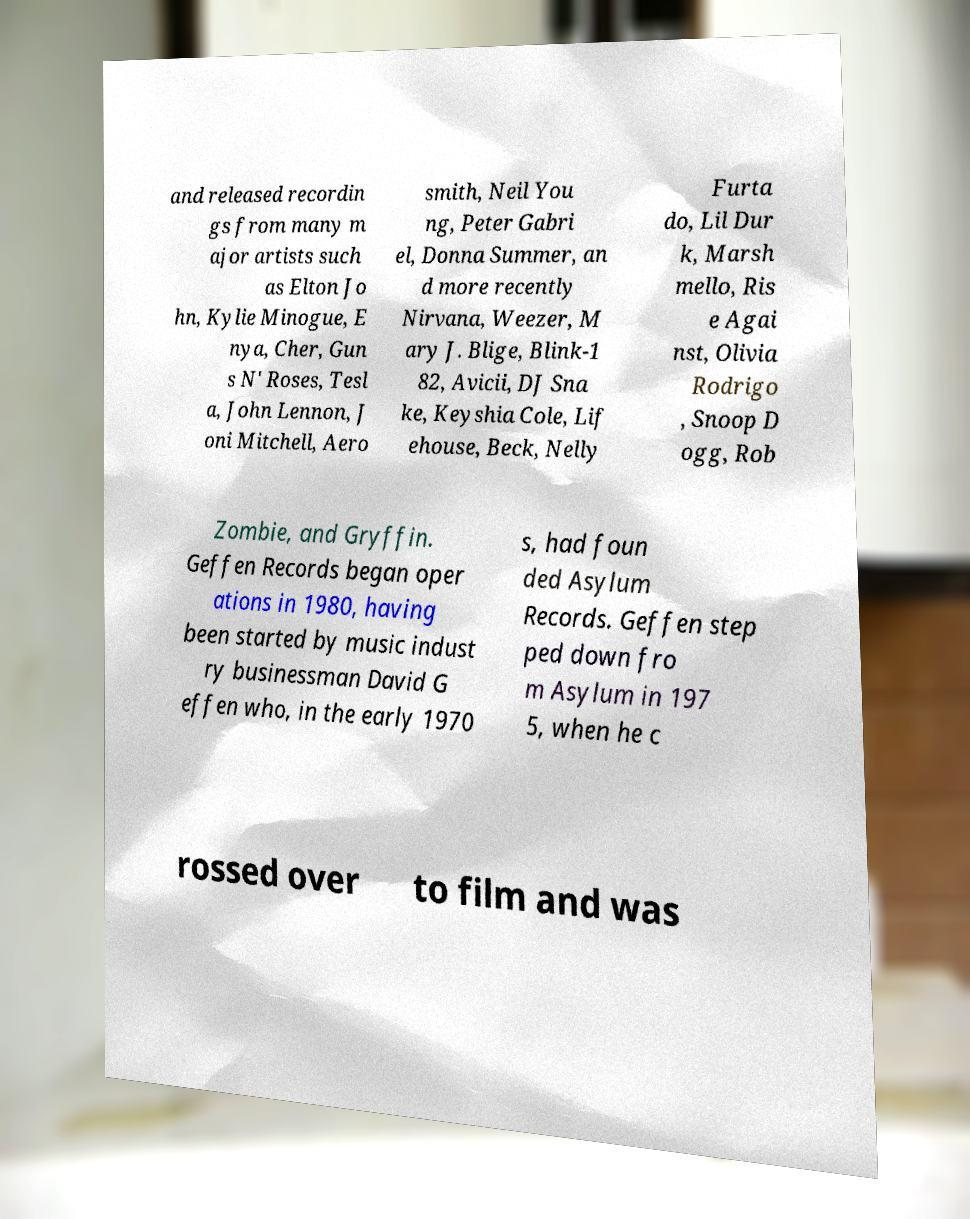Could you extract and type out the text from this image? and released recordin gs from many m ajor artists such as Elton Jo hn, Kylie Minogue, E nya, Cher, Gun s N' Roses, Tesl a, John Lennon, J oni Mitchell, Aero smith, Neil You ng, Peter Gabri el, Donna Summer, an d more recently Nirvana, Weezer, M ary J. Blige, Blink-1 82, Avicii, DJ Sna ke, Keyshia Cole, Lif ehouse, Beck, Nelly Furta do, Lil Dur k, Marsh mello, Ris e Agai nst, Olivia Rodrigo , Snoop D ogg, Rob Zombie, and Gryffin. Geffen Records began oper ations in 1980, having been started by music indust ry businessman David G effen who, in the early 1970 s, had foun ded Asylum Records. Geffen step ped down fro m Asylum in 197 5, when he c rossed over to film and was 